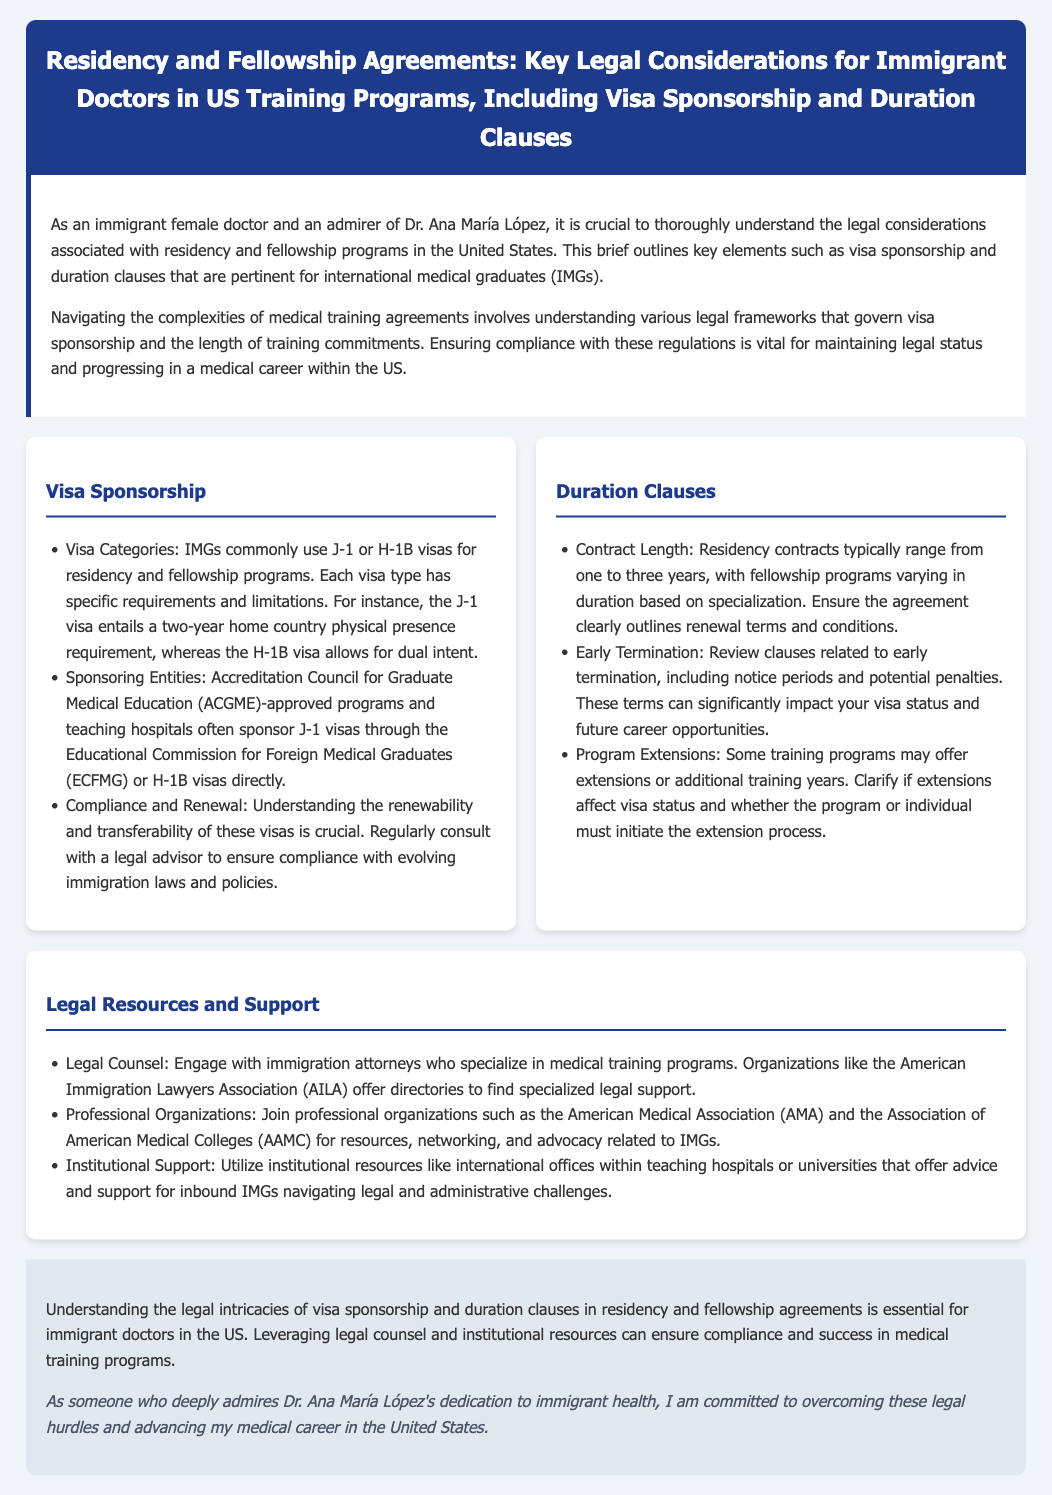What is a common visa used by IMGs? The document mentions that IMGs commonly use J-1 or H-1B visas for residency and fellowship programs.
Answer: J-1 or H-1B What organization sponsors J-1 visas? The document states that the Educational Commission for Foreign Medical Graduates (ECFMG) sponsors J-1 visas.
Answer: ECFMG What is the typical contract length for residency? According to the document, residency contracts typically range from one to three years.
Answer: One to three years What should you review regarding early termination? The document emphasizes reviewing clauses related to early termination, including notice periods and potential penalties.
Answer: Notice periods and potential penalties Who should engage with legal counsel for medical training? The document advises engaging with immigration attorneys who specialize in medical training programs.
Answer: Immigration attorneys How long is the J-1 visa's home country requirement? The document mentions a two-year home country physical presence requirement for J-1 visa holders.
Answer: Two years What is one resource for finding specialized legal support? The document mentions organizations like the American Immigration Lawyers Association (AILA) as a resource.
Answer: American Immigration Lawyers Association What is crucial for maintaining legal status in the US? The document indicates that ensuring compliance with visa regulations is vital for maintaining legal status.
Answer: Compliance with visa regulations 